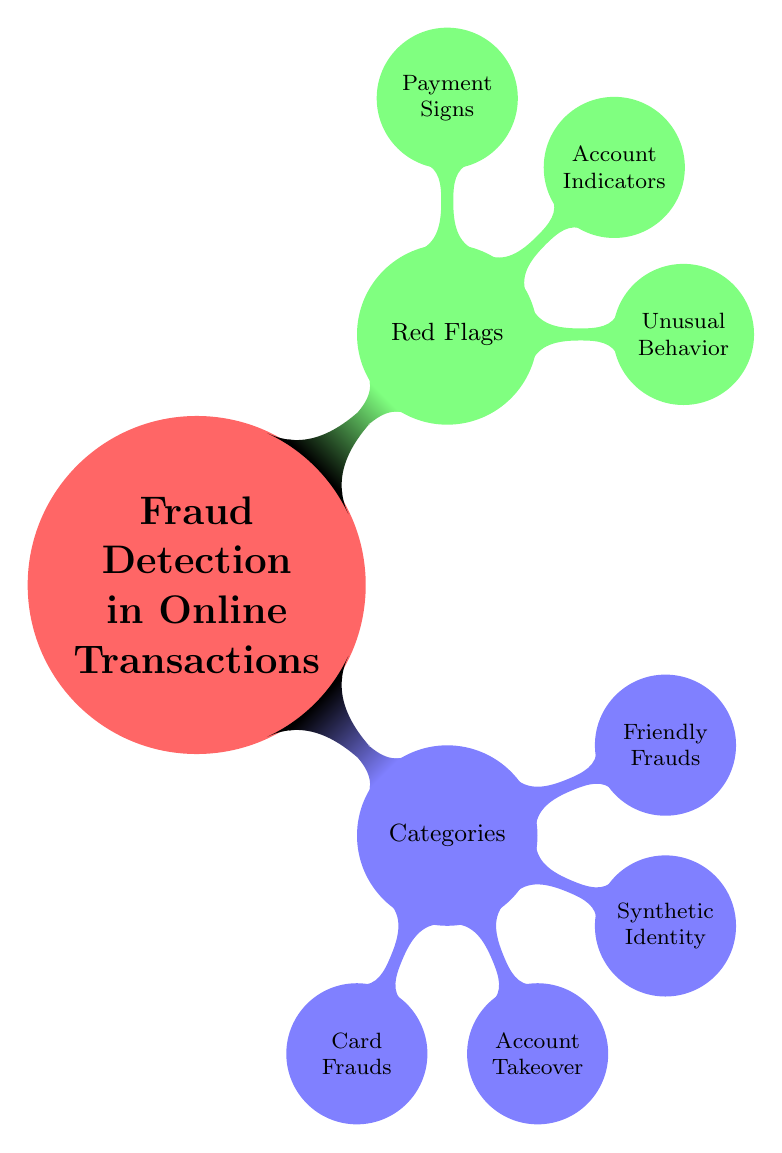What's the main title of the mind map? The main title of the mind map is prominently displayed at the center, which is "Fraud Detection in Online Transactions".
Answer: Fraud Detection in Online Transactions How many categories are there in the diagram? The diagram branches out into four main categories under the "Categories" node. These categories are "Card Frauds", "Account Takeover", "Synthetic Identity", and "Friendly Frauds".
Answer: 4 What is one type of "Card Fraud"? Under the "Card Frauds" category, there are three types listed. One of them is "Stolen Card Information".
Answer: Stolen Card Information What type of red flag is associated with "Unusual Behavior"? The "Red Flags" node includes several indicators, and one specific type associated with "Unusual Behavior" is "Multiple Transactions in Short Time Frame".
Answer: Multiple Transactions in Short Time Frame Which category includes "Credential Stuffing"? "Credential Stuffing" is listed under the "Account Takeover" category, which is one of the four categories mentioned in the diagram.
Answer: Account Takeover How many red flag types are there? The "Red Flags" section features three main types, which are "Unusual Behavior", "Account Indicators", and "Payment Signs".
Answer: 3 What is an example of a "Payment Sign"? Under the "Payment Signs" category, one example provided is "Use of Anonymous Payment Methods".
Answer: Use of Anonymous Payment Methods Which category comprises both "Chargeback Fraud" and "Refund Fraud"? These two types are categorized under "Friendly Frauds", which is one of the categories displayed in the mind map.
Answer: Friendly Frauds What is the relationship between "Synthetic Identity" and "Fake Social Security Numbers"? "Fake Social Security Numbers" is a type listed under the "Synthetic Identity" category, indicating that it is one aspect of synthetic identity fraud.
Answer: Synthetic Identity 